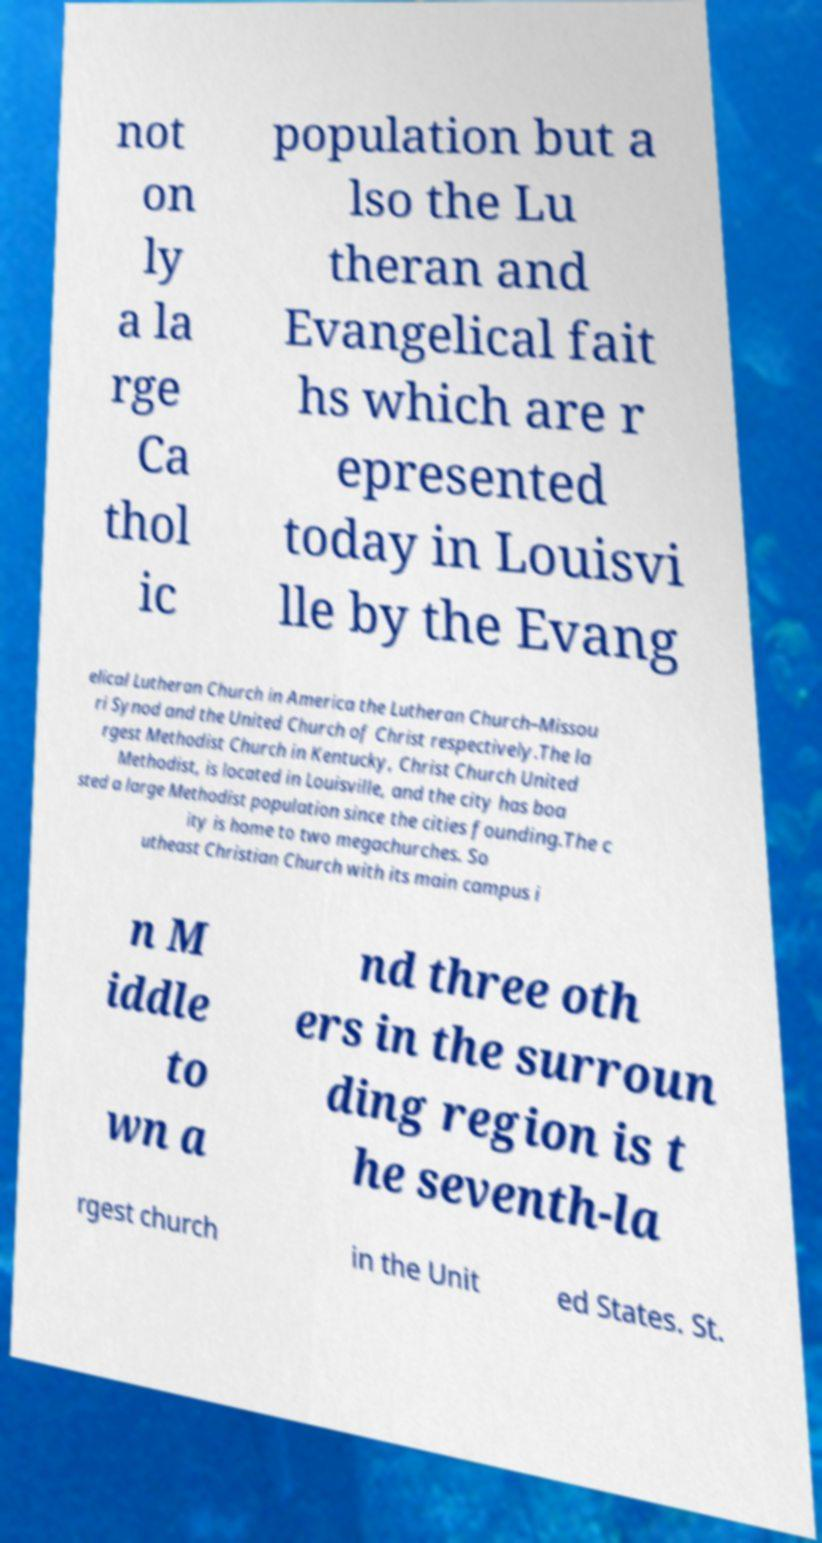There's text embedded in this image that I need extracted. Can you transcribe it verbatim? not on ly a la rge Ca thol ic population but a lso the Lu theran and Evangelical fait hs which are r epresented today in Louisvi lle by the Evang elical Lutheran Church in America the Lutheran Church–Missou ri Synod and the United Church of Christ respectively.The la rgest Methodist Church in Kentucky, Christ Church United Methodist, is located in Louisville, and the city has boa sted a large Methodist population since the cities founding.The c ity is home to two megachurches. So utheast Christian Church with its main campus i n M iddle to wn a nd three oth ers in the surroun ding region is t he seventh-la rgest church in the Unit ed States. St. 